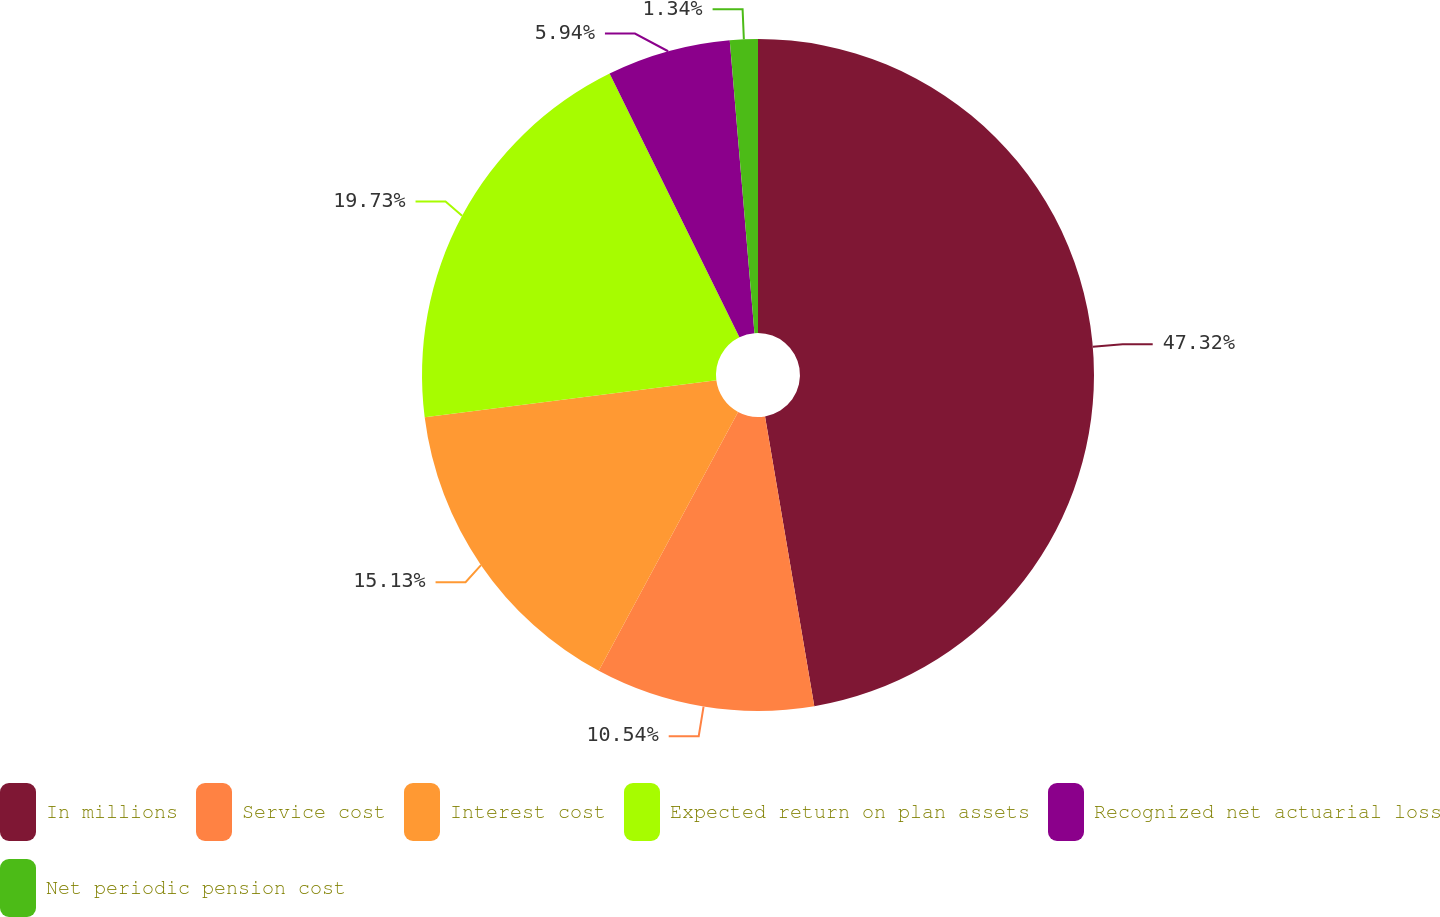Convert chart to OTSL. <chart><loc_0><loc_0><loc_500><loc_500><pie_chart><fcel>In millions<fcel>Service cost<fcel>Interest cost<fcel>Expected return on plan assets<fcel>Recognized net actuarial loss<fcel>Net periodic pension cost<nl><fcel>47.32%<fcel>10.54%<fcel>15.13%<fcel>19.73%<fcel>5.94%<fcel>1.34%<nl></chart> 